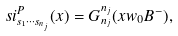<formula> <loc_0><loc_0><loc_500><loc_500>\ s i ^ { P } _ { s _ { 1 } \cdots s _ { n _ { j } } } ( x ) = G ^ { n _ { j } } _ { n _ { j } } ( x w _ { 0 } B ^ { - } ) ,</formula> 